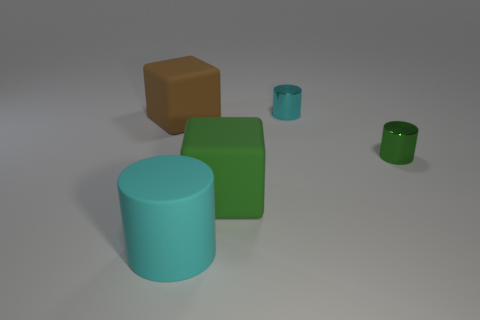Subtract all big cylinders. How many cylinders are left? 2 Add 3 small brown rubber spheres. How many objects exist? 8 Subtract all cylinders. How many objects are left? 2 Add 5 large brown cubes. How many large brown cubes are left? 6 Add 5 big cyan cylinders. How many big cyan cylinders exist? 6 Subtract 1 brown cubes. How many objects are left? 4 Subtract all small metal objects. Subtract all large brown things. How many objects are left? 2 